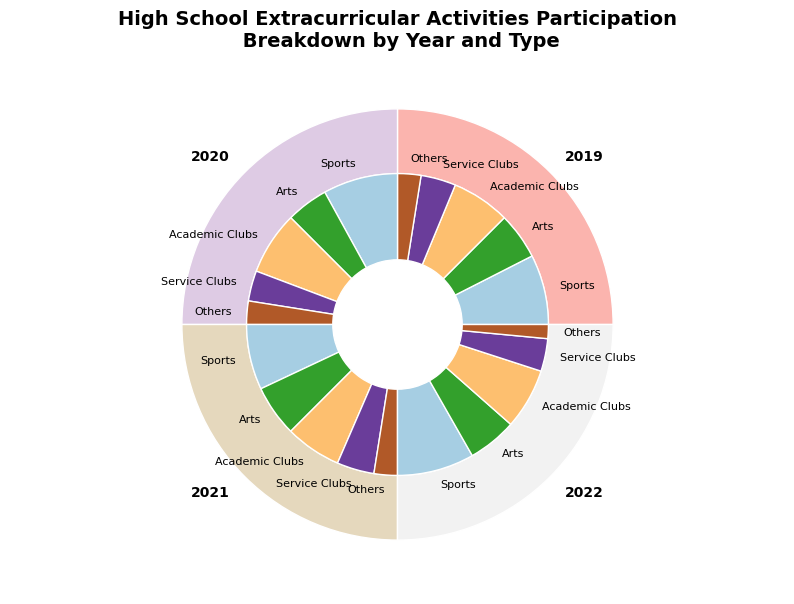What year had the highest total participation in extracurricular activities? To answer this, look at the outer ring of the pie chart and find the segment with the largest size. From the outer ring sectors, we can see the size of each year's participation.
Answer: 2022 Which extracurricular activity type had the most consistent participation over the years? We need to look at the inner ring of the pie chart and compare the sizes of each type across all years. The participation of 'Others' does not significantly change over the years compared to others.
Answer: Others How much more participation did Sports have in 2022 compared to Arts in 2020? First, find the Sports participation in 2022, which is 33, and then find the Arts participation in 2020, which is 18. Calculate the difference: 33 - 18 = 15.
Answer: 15 Which type of activity had the highest increase in participation from 2019 to 2022? Compare the sizes of each type in 2019 and 2022. Sports went from 30 in 2019 to 33 in 2022, which is the highest increase among all types.
Answer: Sports What is the total participation in Service Clubs over the four years? Add the participation in Service Clubs for each year: 15 (2019) + 13 (2020) + 16 (2021) + 14 (2022) = 58.
Answer: 58 Which year had the least participation in 'Others'? Find the smallest segment of the inner ring corresponding to 'Others' over the years. The smallest participation is in 2022 with 6 participants.
Answer: 2022 Is the participation in Academic Clubs in 2021 greater than the total participation in Arts in 2019 and 2020 combined? Find the participation in Academic Clubs for 2021 (24) and sum the participation in Arts for 2019 (20) and 2020 (18): 20 + 18 = 38. Compare 24 to 38.
Answer: No Which visual attribute helps differentiate the years in the chart? Identify the outer pie segments, which use different colors to differentiate each year.
Answer: Color Given the overall trend, can we say sports participation increased steadily from 2019 to 2022? Observe the sports participation segments in each year and compare their sizes: 30 (2019), 32 (2020), 28 (2021), and 33 (2022). Participation did not increase steadily since it decreased in 2021.
Answer: No What was the average participation in Arts over the four years? Sum the participation in Arts for all years: 20 (2019) + 18 (2020) + 22 (2021) + 21 (2022) = 81. Divide by the number of years: 81 / 4 = 20.25.
Answer: 20.25 